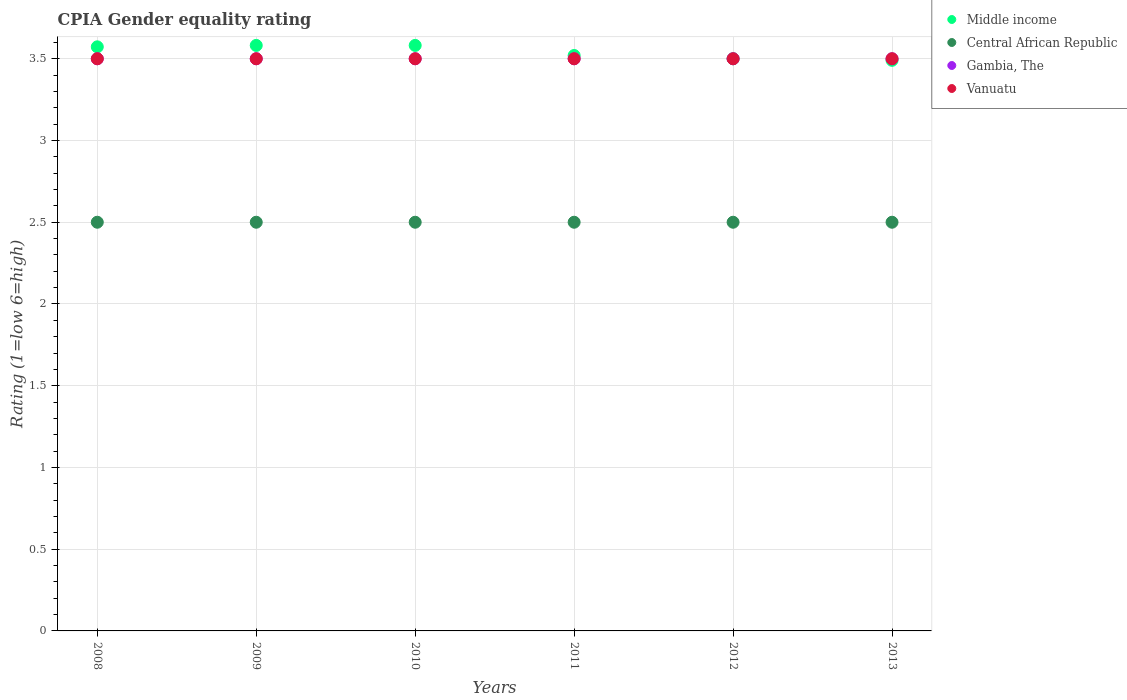How many different coloured dotlines are there?
Provide a succinct answer. 4. Is the number of dotlines equal to the number of legend labels?
Make the answer very short. Yes. What is the CPIA rating in Vanuatu in 2011?
Provide a short and direct response. 3.5. In which year was the CPIA rating in Gambia, The maximum?
Keep it short and to the point. 2008. In which year was the CPIA rating in Central African Republic minimum?
Your answer should be compact. 2008. What is the total CPIA rating in Middle income in the graph?
Provide a short and direct response. 21.25. What is the difference between the CPIA rating in Central African Republic in 2010 and that in 2011?
Provide a short and direct response. 0. What is the average CPIA rating in Gambia, The per year?
Give a very brief answer. 3.5. In how many years, is the CPIA rating in Central African Republic greater than 3.4?
Your response must be concise. 0. What is the ratio of the CPIA rating in Central African Republic in 2008 to that in 2009?
Your answer should be compact. 1. Is the CPIA rating in Gambia, The in 2008 less than that in 2009?
Your response must be concise. No. Is the difference between the CPIA rating in Middle income in 2010 and 2013 greater than the difference between the CPIA rating in Vanuatu in 2010 and 2013?
Your answer should be very brief. Yes. In how many years, is the CPIA rating in Central African Republic greater than the average CPIA rating in Central African Republic taken over all years?
Offer a terse response. 0. Is the sum of the CPIA rating in Vanuatu in 2010 and 2013 greater than the maximum CPIA rating in Middle income across all years?
Your answer should be compact. Yes. Is it the case that in every year, the sum of the CPIA rating in Central African Republic and CPIA rating in Gambia, The  is greater than the sum of CPIA rating in Vanuatu and CPIA rating in Middle income?
Provide a succinct answer. No. Is it the case that in every year, the sum of the CPIA rating in Central African Republic and CPIA rating in Gambia, The  is greater than the CPIA rating in Middle income?
Offer a terse response. Yes. Is the CPIA rating in Middle income strictly less than the CPIA rating in Gambia, The over the years?
Ensure brevity in your answer.  No. How many dotlines are there?
Ensure brevity in your answer.  4. How many years are there in the graph?
Provide a short and direct response. 6. What is the difference between two consecutive major ticks on the Y-axis?
Your answer should be compact. 0.5. Does the graph contain any zero values?
Your answer should be very brief. No. Does the graph contain grids?
Provide a succinct answer. Yes. Where does the legend appear in the graph?
Your response must be concise. Top right. How are the legend labels stacked?
Offer a terse response. Vertical. What is the title of the graph?
Provide a succinct answer. CPIA Gender equality rating. What is the Rating (1=low 6=high) in Middle income in 2008?
Offer a terse response. 3.57. What is the Rating (1=low 6=high) in Central African Republic in 2008?
Offer a terse response. 2.5. What is the Rating (1=low 6=high) of Vanuatu in 2008?
Offer a very short reply. 3.5. What is the Rating (1=low 6=high) of Middle income in 2009?
Your answer should be compact. 3.58. What is the Rating (1=low 6=high) in Vanuatu in 2009?
Provide a succinct answer. 3.5. What is the Rating (1=low 6=high) in Middle income in 2010?
Keep it short and to the point. 3.58. What is the Rating (1=low 6=high) in Central African Republic in 2010?
Make the answer very short. 2.5. What is the Rating (1=low 6=high) in Middle income in 2011?
Make the answer very short. 3.52. What is the Rating (1=low 6=high) in Central African Republic in 2011?
Provide a short and direct response. 2.5. What is the Rating (1=low 6=high) of Middle income in 2012?
Your answer should be very brief. 3.5. What is the Rating (1=low 6=high) in Gambia, The in 2012?
Give a very brief answer. 3.5. What is the Rating (1=low 6=high) in Middle income in 2013?
Make the answer very short. 3.49. What is the Rating (1=low 6=high) in Gambia, The in 2013?
Provide a short and direct response. 3.5. What is the Rating (1=low 6=high) of Vanuatu in 2013?
Your response must be concise. 3.5. Across all years, what is the maximum Rating (1=low 6=high) in Middle income?
Offer a terse response. 3.58. Across all years, what is the maximum Rating (1=low 6=high) in Gambia, The?
Your answer should be very brief. 3.5. Across all years, what is the maximum Rating (1=low 6=high) of Vanuatu?
Your answer should be very brief. 3.5. Across all years, what is the minimum Rating (1=low 6=high) of Middle income?
Offer a very short reply. 3.49. Across all years, what is the minimum Rating (1=low 6=high) of Gambia, The?
Ensure brevity in your answer.  3.5. Across all years, what is the minimum Rating (1=low 6=high) in Vanuatu?
Give a very brief answer. 3.5. What is the total Rating (1=low 6=high) of Middle income in the graph?
Ensure brevity in your answer.  21.25. What is the total Rating (1=low 6=high) of Gambia, The in the graph?
Provide a succinct answer. 21. What is the total Rating (1=low 6=high) of Vanuatu in the graph?
Offer a very short reply. 21. What is the difference between the Rating (1=low 6=high) of Middle income in 2008 and that in 2009?
Ensure brevity in your answer.  -0.01. What is the difference between the Rating (1=low 6=high) of Central African Republic in 2008 and that in 2009?
Keep it short and to the point. 0. What is the difference between the Rating (1=low 6=high) in Gambia, The in 2008 and that in 2009?
Your response must be concise. 0. What is the difference between the Rating (1=low 6=high) of Vanuatu in 2008 and that in 2009?
Your response must be concise. 0. What is the difference between the Rating (1=low 6=high) of Middle income in 2008 and that in 2010?
Offer a terse response. -0.01. What is the difference between the Rating (1=low 6=high) of Gambia, The in 2008 and that in 2010?
Make the answer very short. 0. What is the difference between the Rating (1=low 6=high) in Middle income in 2008 and that in 2011?
Offer a very short reply. 0.05. What is the difference between the Rating (1=low 6=high) of Central African Republic in 2008 and that in 2011?
Your response must be concise. 0. What is the difference between the Rating (1=low 6=high) in Vanuatu in 2008 and that in 2011?
Provide a short and direct response. 0. What is the difference between the Rating (1=low 6=high) in Middle income in 2008 and that in 2012?
Give a very brief answer. 0.07. What is the difference between the Rating (1=low 6=high) of Central African Republic in 2008 and that in 2012?
Offer a very short reply. 0. What is the difference between the Rating (1=low 6=high) in Gambia, The in 2008 and that in 2012?
Ensure brevity in your answer.  0. What is the difference between the Rating (1=low 6=high) in Middle income in 2008 and that in 2013?
Your answer should be very brief. 0.08. What is the difference between the Rating (1=low 6=high) in Central African Republic in 2009 and that in 2010?
Make the answer very short. 0. What is the difference between the Rating (1=low 6=high) in Vanuatu in 2009 and that in 2010?
Make the answer very short. 0. What is the difference between the Rating (1=low 6=high) in Middle income in 2009 and that in 2011?
Your answer should be very brief. 0.06. What is the difference between the Rating (1=low 6=high) in Gambia, The in 2009 and that in 2011?
Ensure brevity in your answer.  0. What is the difference between the Rating (1=low 6=high) of Middle income in 2009 and that in 2012?
Ensure brevity in your answer.  0.08. What is the difference between the Rating (1=low 6=high) of Central African Republic in 2009 and that in 2012?
Offer a terse response. 0. What is the difference between the Rating (1=low 6=high) of Gambia, The in 2009 and that in 2012?
Your answer should be very brief. 0. What is the difference between the Rating (1=low 6=high) of Middle income in 2009 and that in 2013?
Offer a very short reply. 0.09. What is the difference between the Rating (1=low 6=high) in Middle income in 2010 and that in 2011?
Offer a very short reply. 0.06. What is the difference between the Rating (1=low 6=high) of Vanuatu in 2010 and that in 2011?
Offer a terse response. 0. What is the difference between the Rating (1=low 6=high) of Middle income in 2010 and that in 2012?
Make the answer very short. 0.08. What is the difference between the Rating (1=low 6=high) of Central African Republic in 2010 and that in 2012?
Keep it short and to the point. 0. What is the difference between the Rating (1=low 6=high) in Vanuatu in 2010 and that in 2012?
Ensure brevity in your answer.  0. What is the difference between the Rating (1=low 6=high) of Middle income in 2010 and that in 2013?
Offer a terse response. 0.09. What is the difference between the Rating (1=low 6=high) of Vanuatu in 2010 and that in 2013?
Offer a very short reply. 0. What is the difference between the Rating (1=low 6=high) in Middle income in 2011 and that in 2012?
Keep it short and to the point. 0.02. What is the difference between the Rating (1=low 6=high) in Central African Republic in 2011 and that in 2012?
Your response must be concise. 0. What is the difference between the Rating (1=low 6=high) in Middle income in 2011 and that in 2013?
Your response must be concise. 0.03. What is the difference between the Rating (1=low 6=high) in Gambia, The in 2011 and that in 2013?
Provide a short and direct response. 0. What is the difference between the Rating (1=low 6=high) of Vanuatu in 2011 and that in 2013?
Offer a very short reply. 0. What is the difference between the Rating (1=low 6=high) in Middle income in 2012 and that in 2013?
Provide a succinct answer. 0.01. What is the difference between the Rating (1=low 6=high) in Central African Republic in 2012 and that in 2013?
Provide a short and direct response. 0. What is the difference between the Rating (1=low 6=high) in Gambia, The in 2012 and that in 2013?
Provide a succinct answer. 0. What is the difference between the Rating (1=low 6=high) in Vanuatu in 2012 and that in 2013?
Offer a very short reply. 0. What is the difference between the Rating (1=low 6=high) in Middle income in 2008 and the Rating (1=low 6=high) in Central African Republic in 2009?
Keep it short and to the point. 1.07. What is the difference between the Rating (1=low 6=high) of Middle income in 2008 and the Rating (1=low 6=high) of Gambia, The in 2009?
Provide a succinct answer. 0.07. What is the difference between the Rating (1=low 6=high) in Middle income in 2008 and the Rating (1=low 6=high) in Vanuatu in 2009?
Offer a terse response. 0.07. What is the difference between the Rating (1=low 6=high) in Central African Republic in 2008 and the Rating (1=low 6=high) in Vanuatu in 2009?
Your answer should be compact. -1. What is the difference between the Rating (1=low 6=high) in Middle income in 2008 and the Rating (1=low 6=high) in Central African Republic in 2010?
Offer a very short reply. 1.07. What is the difference between the Rating (1=low 6=high) of Middle income in 2008 and the Rating (1=low 6=high) of Gambia, The in 2010?
Ensure brevity in your answer.  0.07. What is the difference between the Rating (1=low 6=high) of Middle income in 2008 and the Rating (1=low 6=high) of Vanuatu in 2010?
Your answer should be compact. 0.07. What is the difference between the Rating (1=low 6=high) of Central African Republic in 2008 and the Rating (1=low 6=high) of Vanuatu in 2010?
Offer a terse response. -1. What is the difference between the Rating (1=low 6=high) in Middle income in 2008 and the Rating (1=low 6=high) in Central African Republic in 2011?
Provide a succinct answer. 1.07. What is the difference between the Rating (1=low 6=high) in Middle income in 2008 and the Rating (1=low 6=high) in Gambia, The in 2011?
Provide a succinct answer. 0.07. What is the difference between the Rating (1=low 6=high) in Middle income in 2008 and the Rating (1=low 6=high) in Vanuatu in 2011?
Your answer should be very brief. 0.07. What is the difference between the Rating (1=low 6=high) in Middle income in 2008 and the Rating (1=low 6=high) in Central African Republic in 2012?
Ensure brevity in your answer.  1.07. What is the difference between the Rating (1=low 6=high) in Middle income in 2008 and the Rating (1=low 6=high) in Gambia, The in 2012?
Provide a short and direct response. 0.07. What is the difference between the Rating (1=low 6=high) in Middle income in 2008 and the Rating (1=low 6=high) in Vanuatu in 2012?
Keep it short and to the point. 0.07. What is the difference between the Rating (1=low 6=high) of Gambia, The in 2008 and the Rating (1=low 6=high) of Vanuatu in 2012?
Provide a succinct answer. 0. What is the difference between the Rating (1=low 6=high) of Middle income in 2008 and the Rating (1=low 6=high) of Central African Republic in 2013?
Your response must be concise. 1.07. What is the difference between the Rating (1=low 6=high) of Middle income in 2008 and the Rating (1=low 6=high) of Gambia, The in 2013?
Your response must be concise. 0.07. What is the difference between the Rating (1=low 6=high) in Middle income in 2008 and the Rating (1=low 6=high) in Vanuatu in 2013?
Your answer should be compact. 0.07. What is the difference between the Rating (1=low 6=high) in Middle income in 2009 and the Rating (1=low 6=high) in Central African Republic in 2010?
Provide a succinct answer. 1.08. What is the difference between the Rating (1=low 6=high) of Middle income in 2009 and the Rating (1=low 6=high) of Gambia, The in 2010?
Provide a short and direct response. 0.08. What is the difference between the Rating (1=low 6=high) of Middle income in 2009 and the Rating (1=low 6=high) of Vanuatu in 2010?
Give a very brief answer. 0.08. What is the difference between the Rating (1=low 6=high) in Central African Republic in 2009 and the Rating (1=low 6=high) in Gambia, The in 2010?
Keep it short and to the point. -1. What is the difference between the Rating (1=low 6=high) of Central African Republic in 2009 and the Rating (1=low 6=high) of Vanuatu in 2010?
Keep it short and to the point. -1. What is the difference between the Rating (1=low 6=high) of Gambia, The in 2009 and the Rating (1=low 6=high) of Vanuatu in 2010?
Ensure brevity in your answer.  0. What is the difference between the Rating (1=low 6=high) of Middle income in 2009 and the Rating (1=low 6=high) of Central African Republic in 2011?
Your answer should be very brief. 1.08. What is the difference between the Rating (1=low 6=high) in Middle income in 2009 and the Rating (1=low 6=high) in Gambia, The in 2011?
Your answer should be very brief. 0.08. What is the difference between the Rating (1=low 6=high) of Middle income in 2009 and the Rating (1=low 6=high) of Vanuatu in 2011?
Offer a terse response. 0.08. What is the difference between the Rating (1=low 6=high) in Central African Republic in 2009 and the Rating (1=low 6=high) in Gambia, The in 2011?
Offer a very short reply. -1. What is the difference between the Rating (1=low 6=high) of Middle income in 2009 and the Rating (1=low 6=high) of Central African Republic in 2012?
Provide a short and direct response. 1.08. What is the difference between the Rating (1=low 6=high) of Middle income in 2009 and the Rating (1=low 6=high) of Gambia, The in 2012?
Offer a very short reply. 0.08. What is the difference between the Rating (1=low 6=high) in Middle income in 2009 and the Rating (1=low 6=high) in Vanuatu in 2012?
Your answer should be very brief. 0.08. What is the difference between the Rating (1=low 6=high) of Central African Republic in 2009 and the Rating (1=low 6=high) of Vanuatu in 2012?
Your response must be concise. -1. What is the difference between the Rating (1=low 6=high) of Middle income in 2009 and the Rating (1=low 6=high) of Central African Republic in 2013?
Make the answer very short. 1.08. What is the difference between the Rating (1=low 6=high) of Middle income in 2009 and the Rating (1=low 6=high) of Gambia, The in 2013?
Your answer should be very brief. 0.08. What is the difference between the Rating (1=low 6=high) of Middle income in 2009 and the Rating (1=low 6=high) of Vanuatu in 2013?
Offer a terse response. 0.08. What is the difference between the Rating (1=low 6=high) of Middle income in 2010 and the Rating (1=low 6=high) of Central African Republic in 2011?
Make the answer very short. 1.08. What is the difference between the Rating (1=low 6=high) of Middle income in 2010 and the Rating (1=low 6=high) of Gambia, The in 2011?
Provide a succinct answer. 0.08. What is the difference between the Rating (1=low 6=high) in Middle income in 2010 and the Rating (1=low 6=high) in Vanuatu in 2011?
Ensure brevity in your answer.  0.08. What is the difference between the Rating (1=low 6=high) of Central African Republic in 2010 and the Rating (1=low 6=high) of Vanuatu in 2011?
Give a very brief answer. -1. What is the difference between the Rating (1=low 6=high) of Middle income in 2010 and the Rating (1=low 6=high) of Central African Republic in 2012?
Provide a succinct answer. 1.08. What is the difference between the Rating (1=low 6=high) in Middle income in 2010 and the Rating (1=low 6=high) in Gambia, The in 2012?
Provide a succinct answer. 0.08. What is the difference between the Rating (1=low 6=high) of Middle income in 2010 and the Rating (1=low 6=high) of Vanuatu in 2012?
Offer a very short reply. 0.08. What is the difference between the Rating (1=low 6=high) of Middle income in 2010 and the Rating (1=low 6=high) of Central African Republic in 2013?
Make the answer very short. 1.08. What is the difference between the Rating (1=low 6=high) in Middle income in 2010 and the Rating (1=low 6=high) in Gambia, The in 2013?
Your answer should be very brief. 0.08. What is the difference between the Rating (1=low 6=high) of Middle income in 2010 and the Rating (1=low 6=high) of Vanuatu in 2013?
Provide a short and direct response. 0.08. What is the difference between the Rating (1=low 6=high) of Central African Republic in 2010 and the Rating (1=low 6=high) of Vanuatu in 2013?
Ensure brevity in your answer.  -1. What is the difference between the Rating (1=low 6=high) in Middle income in 2011 and the Rating (1=low 6=high) in Central African Republic in 2012?
Offer a terse response. 1.02. What is the difference between the Rating (1=low 6=high) of Middle income in 2011 and the Rating (1=low 6=high) of Vanuatu in 2012?
Keep it short and to the point. 0.02. What is the difference between the Rating (1=low 6=high) in Central African Republic in 2011 and the Rating (1=low 6=high) in Gambia, The in 2012?
Give a very brief answer. -1. What is the difference between the Rating (1=low 6=high) in Central African Republic in 2011 and the Rating (1=low 6=high) in Vanuatu in 2012?
Provide a short and direct response. -1. What is the difference between the Rating (1=low 6=high) in Gambia, The in 2011 and the Rating (1=low 6=high) in Vanuatu in 2012?
Your response must be concise. 0. What is the difference between the Rating (1=low 6=high) of Middle income in 2011 and the Rating (1=low 6=high) of Vanuatu in 2013?
Your answer should be compact. 0.02. What is the difference between the Rating (1=low 6=high) of Central African Republic in 2011 and the Rating (1=low 6=high) of Vanuatu in 2013?
Give a very brief answer. -1. What is the difference between the Rating (1=low 6=high) of Middle income in 2012 and the Rating (1=low 6=high) of Central African Republic in 2013?
Offer a very short reply. 1. What is the difference between the Rating (1=low 6=high) of Middle income in 2012 and the Rating (1=low 6=high) of Gambia, The in 2013?
Keep it short and to the point. 0. What is the difference between the Rating (1=low 6=high) of Middle income in 2012 and the Rating (1=low 6=high) of Vanuatu in 2013?
Your response must be concise. 0. What is the difference between the Rating (1=low 6=high) of Central African Republic in 2012 and the Rating (1=low 6=high) of Gambia, The in 2013?
Keep it short and to the point. -1. What is the difference between the Rating (1=low 6=high) of Gambia, The in 2012 and the Rating (1=low 6=high) of Vanuatu in 2013?
Give a very brief answer. 0. What is the average Rating (1=low 6=high) of Middle income per year?
Ensure brevity in your answer.  3.54. In the year 2008, what is the difference between the Rating (1=low 6=high) of Middle income and Rating (1=low 6=high) of Central African Republic?
Provide a succinct answer. 1.07. In the year 2008, what is the difference between the Rating (1=low 6=high) in Middle income and Rating (1=low 6=high) in Gambia, The?
Make the answer very short. 0.07. In the year 2008, what is the difference between the Rating (1=low 6=high) of Middle income and Rating (1=low 6=high) of Vanuatu?
Offer a very short reply. 0.07. In the year 2008, what is the difference between the Rating (1=low 6=high) of Central African Republic and Rating (1=low 6=high) of Gambia, The?
Offer a terse response. -1. In the year 2008, what is the difference between the Rating (1=low 6=high) in Central African Republic and Rating (1=low 6=high) in Vanuatu?
Provide a short and direct response. -1. In the year 2009, what is the difference between the Rating (1=low 6=high) in Middle income and Rating (1=low 6=high) in Central African Republic?
Give a very brief answer. 1.08. In the year 2009, what is the difference between the Rating (1=low 6=high) of Middle income and Rating (1=low 6=high) of Gambia, The?
Provide a succinct answer. 0.08. In the year 2009, what is the difference between the Rating (1=low 6=high) of Middle income and Rating (1=low 6=high) of Vanuatu?
Your answer should be compact. 0.08. In the year 2009, what is the difference between the Rating (1=low 6=high) in Central African Republic and Rating (1=low 6=high) in Gambia, The?
Provide a succinct answer. -1. In the year 2009, what is the difference between the Rating (1=low 6=high) of Central African Republic and Rating (1=low 6=high) of Vanuatu?
Your response must be concise. -1. In the year 2009, what is the difference between the Rating (1=low 6=high) of Gambia, The and Rating (1=low 6=high) of Vanuatu?
Offer a terse response. 0. In the year 2010, what is the difference between the Rating (1=low 6=high) in Middle income and Rating (1=low 6=high) in Central African Republic?
Offer a terse response. 1.08. In the year 2010, what is the difference between the Rating (1=low 6=high) of Middle income and Rating (1=low 6=high) of Gambia, The?
Offer a very short reply. 0.08. In the year 2010, what is the difference between the Rating (1=low 6=high) of Middle income and Rating (1=low 6=high) of Vanuatu?
Your answer should be very brief. 0.08. In the year 2010, what is the difference between the Rating (1=low 6=high) in Central African Republic and Rating (1=low 6=high) in Gambia, The?
Offer a very short reply. -1. In the year 2010, what is the difference between the Rating (1=low 6=high) of Central African Republic and Rating (1=low 6=high) of Vanuatu?
Provide a short and direct response. -1. In the year 2010, what is the difference between the Rating (1=low 6=high) in Gambia, The and Rating (1=low 6=high) in Vanuatu?
Ensure brevity in your answer.  0. In the year 2011, what is the difference between the Rating (1=low 6=high) of Middle income and Rating (1=low 6=high) of Gambia, The?
Provide a short and direct response. 0.02. In the year 2011, what is the difference between the Rating (1=low 6=high) in Gambia, The and Rating (1=low 6=high) in Vanuatu?
Your response must be concise. 0. In the year 2012, what is the difference between the Rating (1=low 6=high) of Middle income and Rating (1=low 6=high) of Gambia, The?
Your answer should be very brief. 0. In the year 2012, what is the difference between the Rating (1=low 6=high) of Central African Republic and Rating (1=low 6=high) of Gambia, The?
Your response must be concise. -1. In the year 2012, what is the difference between the Rating (1=low 6=high) of Central African Republic and Rating (1=low 6=high) of Vanuatu?
Provide a succinct answer. -1. In the year 2013, what is the difference between the Rating (1=low 6=high) of Middle income and Rating (1=low 6=high) of Central African Republic?
Offer a terse response. 0.99. In the year 2013, what is the difference between the Rating (1=low 6=high) of Middle income and Rating (1=low 6=high) of Gambia, The?
Ensure brevity in your answer.  -0.01. In the year 2013, what is the difference between the Rating (1=low 6=high) in Middle income and Rating (1=low 6=high) in Vanuatu?
Your response must be concise. -0.01. In the year 2013, what is the difference between the Rating (1=low 6=high) of Central African Republic and Rating (1=low 6=high) of Gambia, The?
Offer a terse response. -1. In the year 2013, what is the difference between the Rating (1=low 6=high) of Gambia, The and Rating (1=low 6=high) of Vanuatu?
Keep it short and to the point. 0. What is the ratio of the Rating (1=low 6=high) of Middle income in 2008 to that in 2009?
Offer a terse response. 1. What is the ratio of the Rating (1=low 6=high) in Gambia, The in 2008 to that in 2009?
Give a very brief answer. 1. What is the ratio of the Rating (1=low 6=high) of Vanuatu in 2008 to that in 2011?
Give a very brief answer. 1. What is the ratio of the Rating (1=low 6=high) of Middle income in 2008 to that in 2012?
Ensure brevity in your answer.  1.02. What is the ratio of the Rating (1=low 6=high) of Vanuatu in 2008 to that in 2012?
Offer a terse response. 1. What is the ratio of the Rating (1=low 6=high) of Middle income in 2008 to that in 2013?
Ensure brevity in your answer.  1.02. What is the ratio of the Rating (1=low 6=high) in Central African Republic in 2008 to that in 2013?
Your response must be concise. 1. What is the ratio of the Rating (1=low 6=high) in Middle income in 2009 to that in 2010?
Provide a short and direct response. 1. What is the ratio of the Rating (1=low 6=high) in Central African Republic in 2009 to that in 2010?
Offer a very short reply. 1. What is the ratio of the Rating (1=low 6=high) in Gambia, The in 2009 to that in 2010?
Make the answer very short. 1. What is the ratio of the Rating (1=low 6=high) of Middle income in 2009 to that in 2011?
Your response must be concise. 1.02. What is the ratio of the Rating (1=low 6=high) in Gambia, The in 2009 to that in 2011?
Ensure brevity in your answer.  1. What is the ratio of the Rating (1=low 6=high) of Middle income in 2009 to that in 2012?
Provide a succinct answer. 1.02. What is the ratio of the Rating (1=low 6=high) of Middle income in 2009 to that in 2013?
Your answer should be compact. 1.03. What is the ratio of the Rating (1=low 6=high) in Central African Republic in 2009 to that in 2013?
Your answer should be compact. 1. What is the ratio of the Rating (1=low 6=high) of Gambia, The in 2009 to that in 2013?
Offer a terse response. 1. What is the ratio of the Rating (1=low 6=high) in Middle income in 2010 to that in 2011?
Your answer should be very brief. 1.02. What is the ratio of the Rating (1=low 6=high) in Central African Republic in 2010 to that in 2011?
Give a very brief answer. 1. What is the ratio of the Rating (1=low 6=high) of Middle income in 2010 to that in 2012?
Offer a very short reply. 1.02. What is the ratio of the Rating (1=low 6=high) in Middle income in 2010 to that in 2013?
Keep it short and to the point. 1.03. What is the ratio of the Rating (1=low 6=high) of Central African Republic in 2010 to that in 2013?
Your response must be concise. 1. What is the ratio of the Rating (1=low 6=high) in Vanuatu in 2010 to that in 2013?
Your response must be concise. 1. What is the ratio of the Rating (1=low 6=high) of Middle income in 2011 to that in 2013?
Give a very brief answer. 1.01. What is the ratio of the Rating (1=low 6=high) of Gambia, The in 2011 to that in 2013?
Ensure brevity in your answer.  1. What is the ratio of the Rating (1=low 6=high) of Vanuatu in 2011 to that in 2013?
Provide a succinct answer. 1. What is the ratio of the Rating (1=low 6=high) of Middle income in 2012 to that in 2013?
Ensure brevity in your answer.  1. What is the ratio of the Rating (1=low 6=high) of Gambia, The in 2012 to that in 2013?
Your answer should be very brief. 1. What is the difference between the highest and the second highest Rating (1=low 6=high) of Middle income?
Offer a terse response. 0. What is the difference between the highest and the second highest Rating (1=low 6=high) in Gambia, The?
Your answer should be compact. 0. What is the difference between the highest and the second highest Rating (1=low 6=high) in Vanuatu?
Your answer should be very brief. 0. What is the difference between the highest and the lowest Rating (1=low 6=high) of Middle income?
Offer a very short reply. 0.09. What is the difference between the highest and the lowest Rating (1=low 6=high) of Central African Republic?
Your answer should be very brief. 0. What is the difference between the highest and the lowest Rating (1=low 6=high) in Gambia, The?
Offer a terse response. 0. 